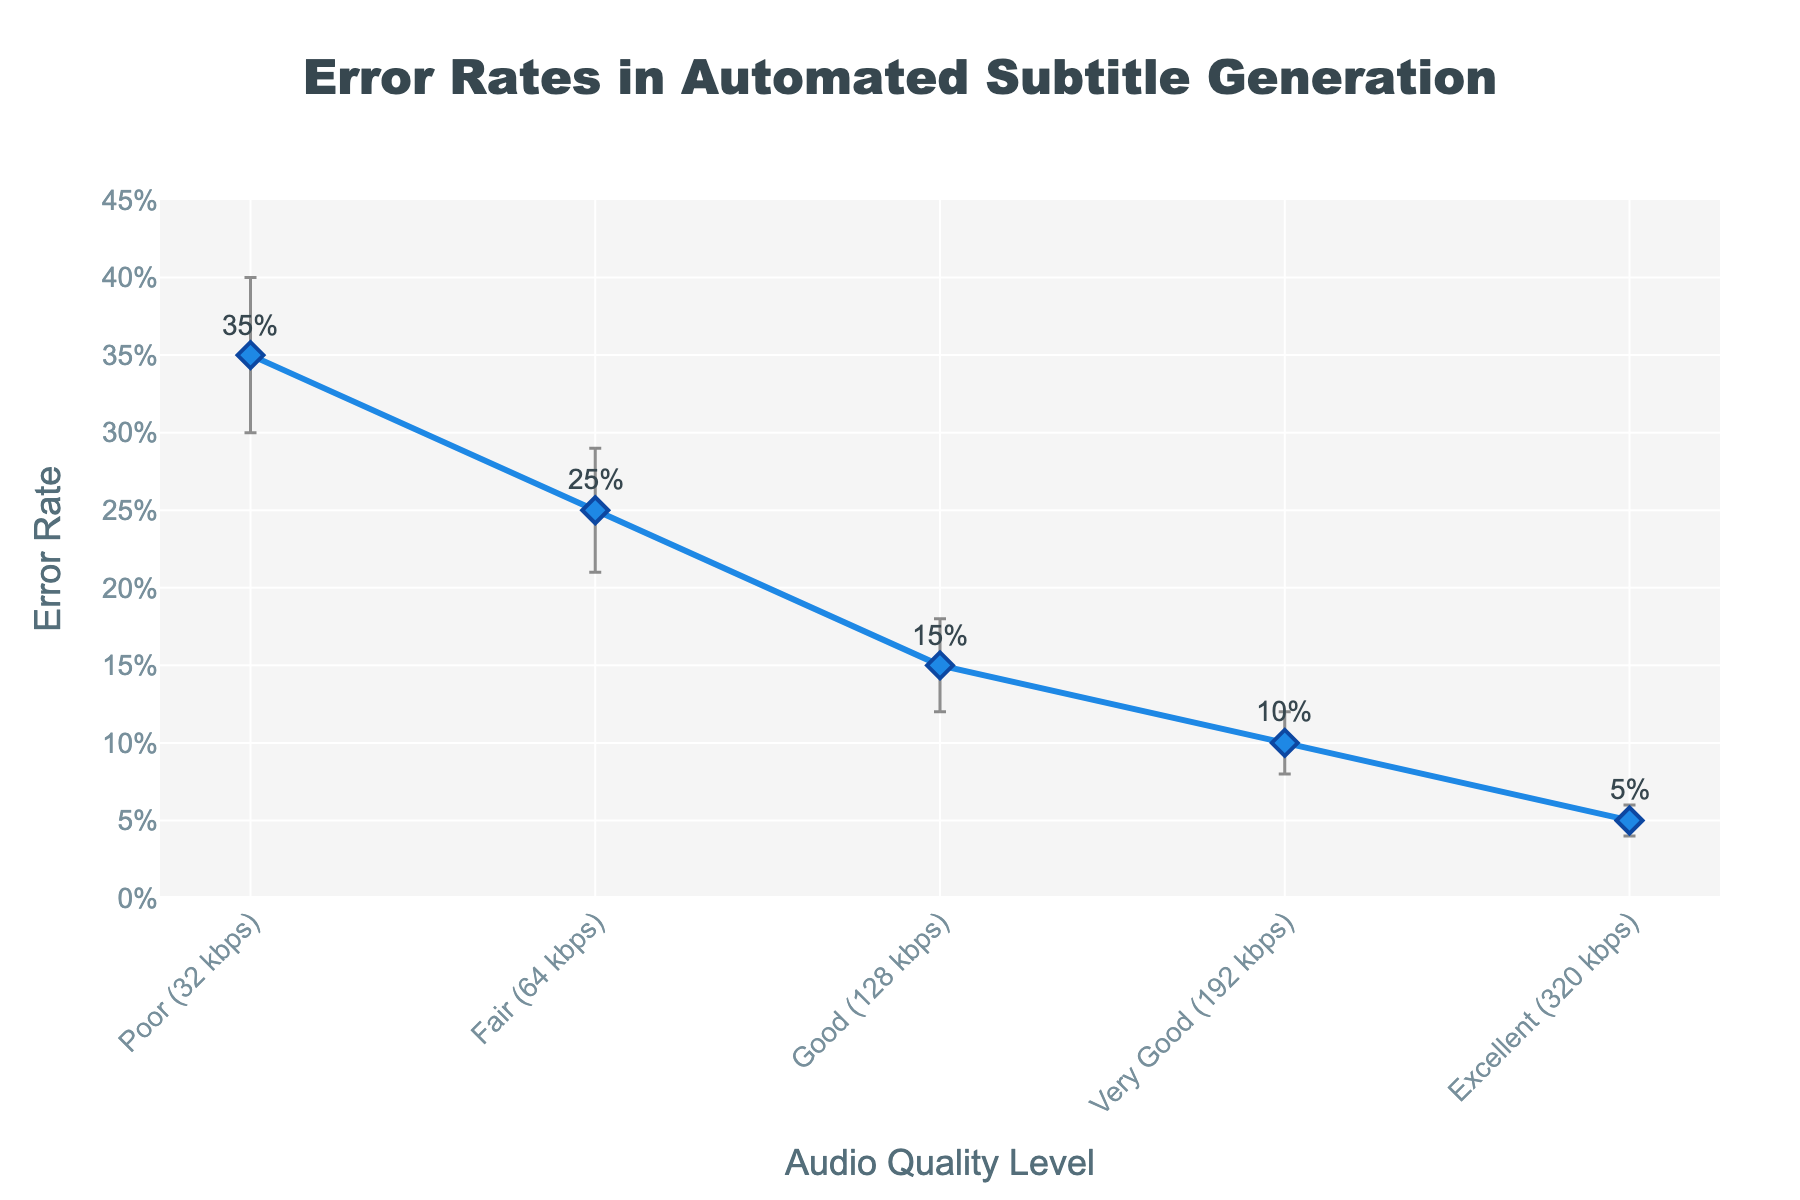What's the title of the plot? The title is shown at the top of the figure. It reads "Error Rates in Automated Subtitle Generation," which is clearly indicated in bold, large font.
Answer: Error Rates in Automated Subtitle Generation What does the y-axis represent? The y-axis is labeled "Error Rate," indicating it measures the error rate of subtitle generation. This is displayed along the vertical axis of the plot.
Answer: Error Rate How many audio quality levels are analyzed in this plot? There are five distinct audio quality levels listed on the x-axis: Poor (32 kbps), Fair (64 kbps), Good (128 kbps), Very Good (192 kbps), and Excellent (320 kbps).
Answer: Five Which audio quality level has the highest error rate? By examining the data points and their positions along the y-axis, the "Poor (32 kbps)" level shows the highest error rate of 0.35.
Answer: Poor (32 kbps) What is the error rate at the "Good (128 kbps)" audio quality level? The plot clearly marks the error rate at "Good (128 kbps)" as 0.15.
Answer: 0.15 What is the range of error rates covered in this plot? The error rates range from the highest point at Poor (32 kbps) 0.35 to the lowest point at Excellent (320 kbps) 0.05.
Answer: 0.05 to 0.35 What does the shaded area around the line signify? The shaded area around the line represents the error margin for each error rate, providing a visual indication of the uncertainty or variability in the measurements.
Answer: Error Margin How does the error rate change as audio quality improves? By evaluating the trend of the line from left to right, it is clear that the error rate decreases as the audio quality improves. This is indicated by the downward slope of the line.
Answer: Decreases What is the average error rate across all audio quality levels? To find the average error rate, sum the error rates (0.35 + 0.25 + 0.15 + 0.10 + 0.05) = 0.90, then divide by the number of levels (5), resulting in an average of 0.18.
Answer: 0.18 Which two audio quality levels have the same error margin? Examining the error margins, both "Fair (64 kbps)" and "Very Good (192 kbps)" have an error margin of 0.04 and 0.02, respectively.
Answer: Fair (64 kbps) & Very Good (192 kbps) 